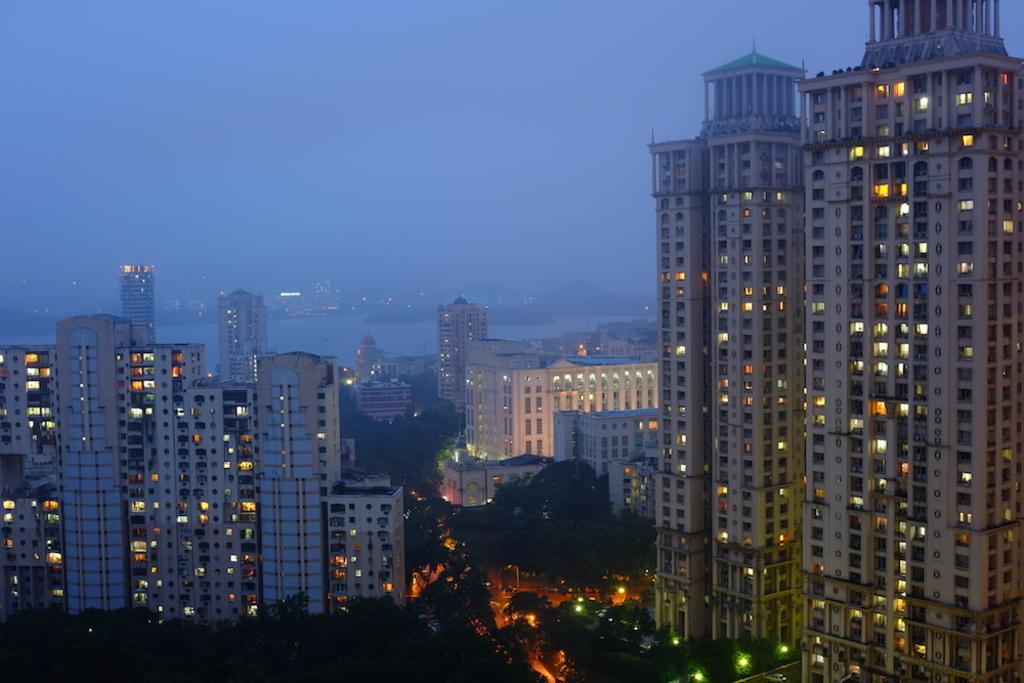How would you summarize this image in a sentence or two? In this image we can see a group of buildings. Inside the building we can see the lights. At the bottom we can see a group of trees. Behind the buildings we can see the water and buildings. At the top we can see the sky. 